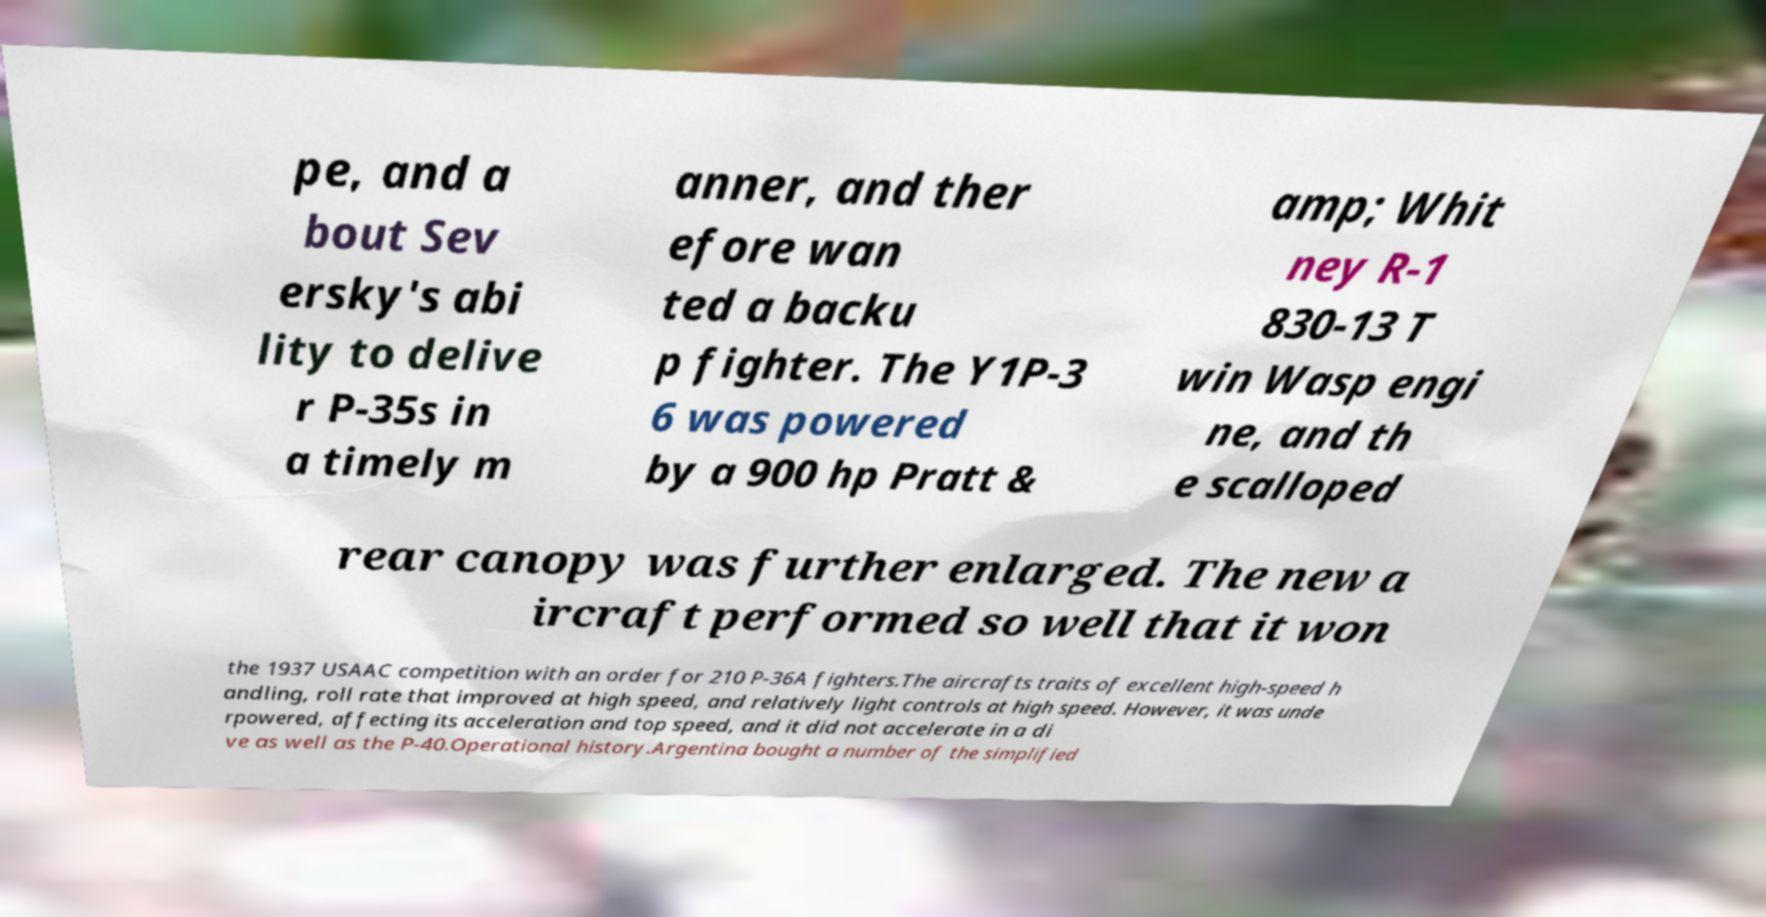What messages or text are displayed in this image? I need them in a readable, typed format. pe, and a bout Sev ersky's abi lity to delive r P-35s in a timely m anner, and ther efore wan ted a backu p fighter. The Y1P-3 6 was powered by a 900 hp Pratt & amp; Whit ney R-1 830-13 T win Wasp engi ne, and th e scalloped rear canopy was further enlarged. The new a ircraft performed so well that it won the 1937 USAAC competition with an order for 210 P-36A fighters.The aircrafts traits of excellent high-speed h andling, roll rate that improved at high speed, and relatively light controls at high speed. However, it was unde rpowered, affecting its acceleration and top speed, and it did not accelerate in a di ve as well as the P-40.Operational history.Argentina bought a number of the simplified 